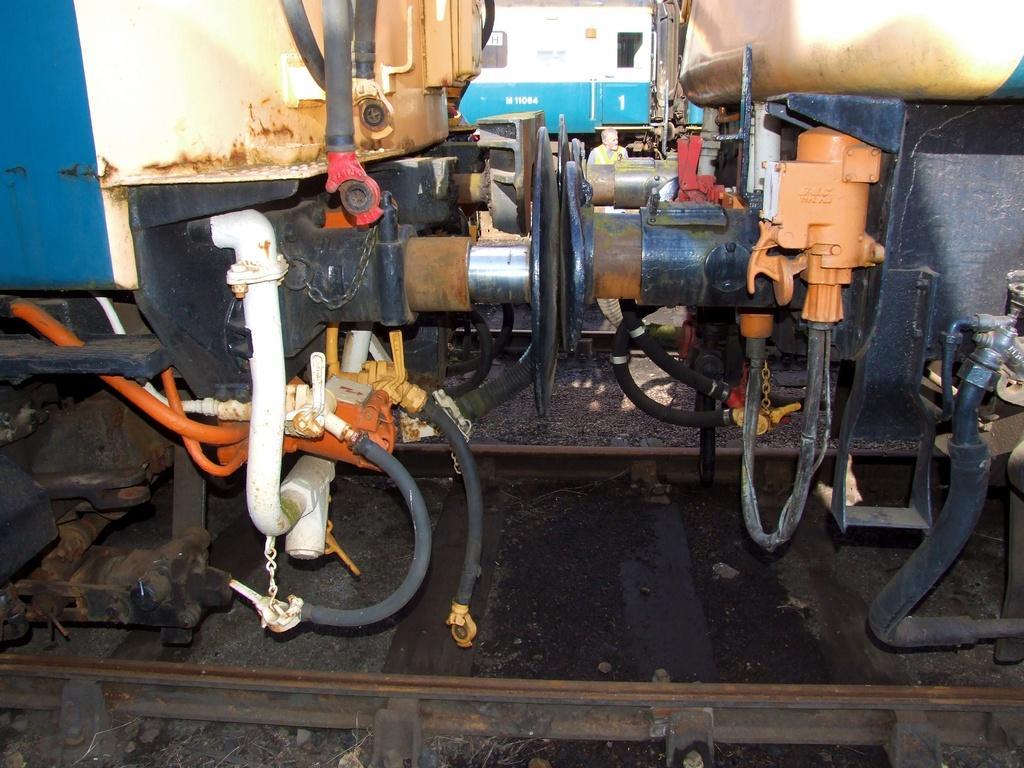How would you summarize this image in a sentence or two? In this image I can see few trains on the railway tracks. They are in different color. 